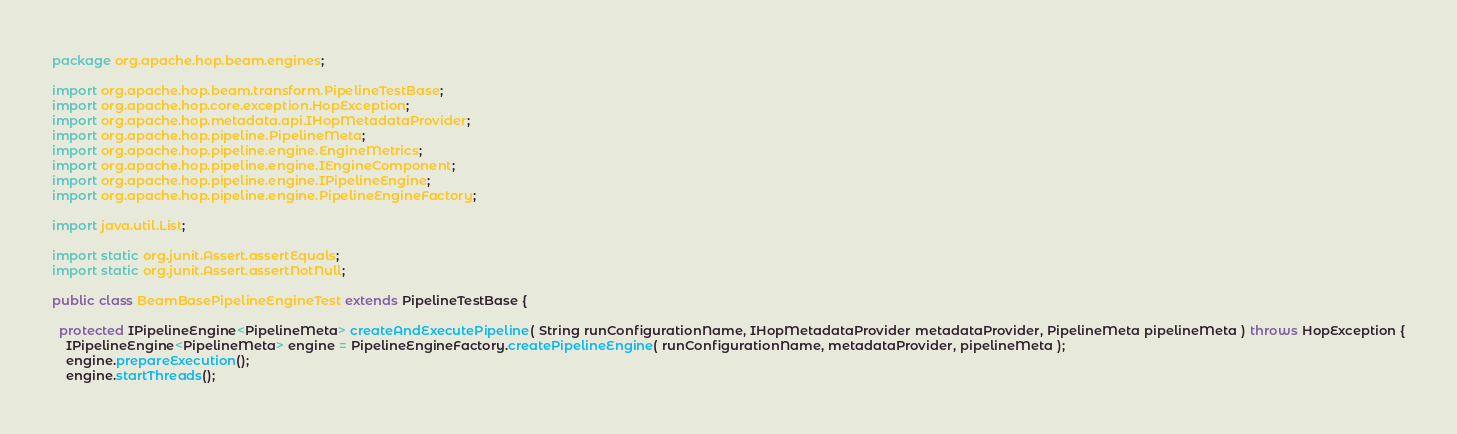Convert code to text. <code><loc_0><loc_0><loc_500><loc_500><_Java_>package org.apache.hop.beam.engines;

import org.apache.hop.beam.transform.PipelineTestBase;
import org.apache.hop.core.exception.HopException;
import org.apache.hop.metadata.api.IHopMetadataProvider;
import org.apache.hop.pipeline.PipelineMeta;
import org.apache.hop.pipeline.engine.EngineMetrics;
import org.apache.hop.pipeline.engine.IEngineComponent;
import org.apache.hop.pipeline.engine.IPipelineEngine;
import org.apache.hop.pipeline.engine.PipelineEngineFactory;

import java.util.List;

import static org.junit.Assert.assertEquals;
import static org.junit.Assert.assertNotNull;

public class BeamBasePipelineEngineTest extends PipelineTestBase {

  protected IPipelineEngine<PipelineMeta> createAndExecutePipeline( String runConfigurationName, IHopMetadataProvider metadataProvider, PipelineMeta pipelineMeta ) throws HopException {
    IPipelineEngine<PipelineMeta> engine = PipelineEngineFactory.createPipelineEngine( runConfigurationName, metadataProvider, pipelineMeta );
    engine.prepareExecution();
    engine.startThreads();</code> 